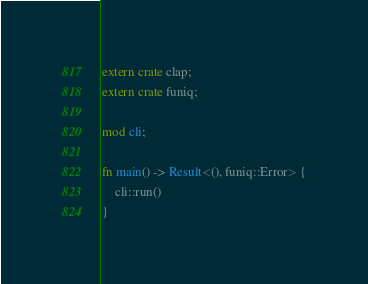Convert code to text. <code><loc_0><loc_0><loc_500><loc_500><_Rust_>extern crate clap;
extern crate funiq;

mod cli;

fn main() -> Result<(), funiq::Error> {
    cli::run()
}
</code> 